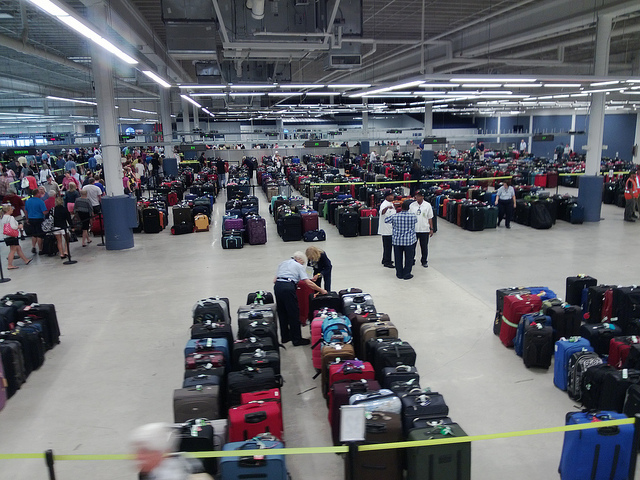<image>What are the people in line on the far right waiting to do? I am not sure what the people in line on the far right are waiting to do. It might be to collect luggage, check in baggage, or exit. What are the people in line on the far right waiting to do? I am not sure what the people in line on the far right are waiting to do. It can be either collecting luggage, getting luggage, or checking in baggage. 